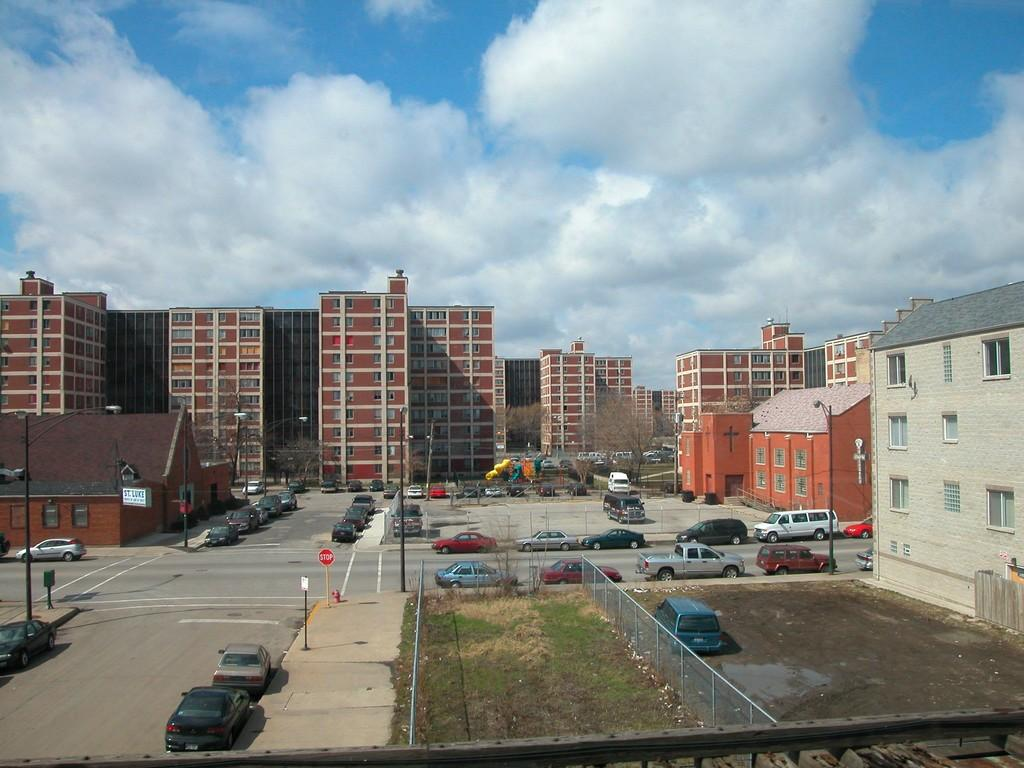What type of structures can be seen in the image? There are buildings in the image. What other natural elements are present in the image? There are trees in the image. What mode of transportation can be seen in the image? Motor vehicles are present on the road and in parking slots. What type of barriers are visible in the image? Fences are visible in the image. What type of informational signs are present in the image? Sign boards are present in the image. What type of vertical structures are visible in the image? Street poles are visible in the image. What type of lighting is present in the image? Street lights are present in the image. What part of the natural environment is visible in the image? The sky is visible in the image. What type of clouds are present in the sky? Clouds are present in the sky. What type of musical instrument can be seen in the image? There is no musical instrument present in the image. 